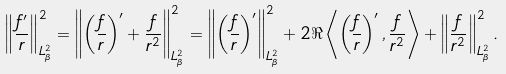<formula> <loc_0><loc_0><loc_500><loc_500>\left \| \frac { f ^ { \prime } } { r } \right \| _ { L _ { \beta } ^ { 2 } } ^ { 2 } = \left \| \left ( \frac { f } { r } \right ) ^ { \prime } + \frac { f } { r ^ { 2 } } \right \| _ { L _ { \beta } ^ { 2 } } ^ { 2 } = \left \| \left ( \frac { f } { r } \right ) ^ { \prime } \right \| _ { L _ { \beta } ^ { 2 } } ^ { 2 } + 2 \Re \left \langle \left ( \frac { f } { r } \right ) ^ { \prime } , \frac { f } { r ^ { 2 } } \right \rangle + \left \| \frac { f } { r ^ { 2 } } \right \| _ { L _ { \beta } ^ { 2 } } ^ { 2 } .</formula> 